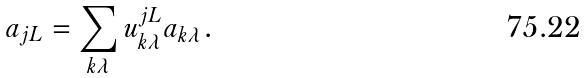Convert formula to latex. <formula><loc_0><loc_0><loc_500><loc_500>a _ { j L } = \sum _ { k \lambda } u _ { k \lambda } ^ { j L } a _ { k \lambda } .</formula> 